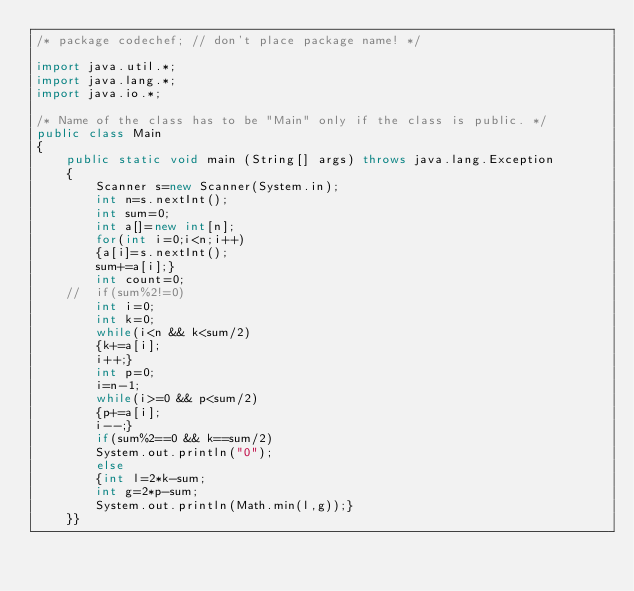Convert code to text. <code><loc_0><loc_0><loc_500><loc_500><_Java_>/* package codechef; // don't place package name! */

import java.util.*;
import java.lang.*;
import java.io.*;

/* Name of the class has to be "Main" only if the class is public. */
public class Main
{
	public static void main (String[] args) throws java.lang.Exception
	{
		Scanner s=new Scanner(System.in);
		int n=s.nextInt();
		int sum=0;
		int a[]=new int[n];
		for(int i=0;i<n;i++)
		{a[i]=s.nextInt();
		sum+=a[i];}
		int count=0;
	//	if(sum%2!=0)
		int i=0;
		int k=0;
		while(i<n && k<sum/2)
		{k+=a[i];
		i++;}
		int p=0;
		i=n-1;
		while(i>=0 && p<sum/2)
		{p+=a[i];
		i--;}
		if(sum%2==0 && k==sum/2)
		System.out.println("0");
		else
		{int l=2*k-sum;
		int g=2*p-sum;
		System.out.println(Math.min(l,g));}
	}}</code> 